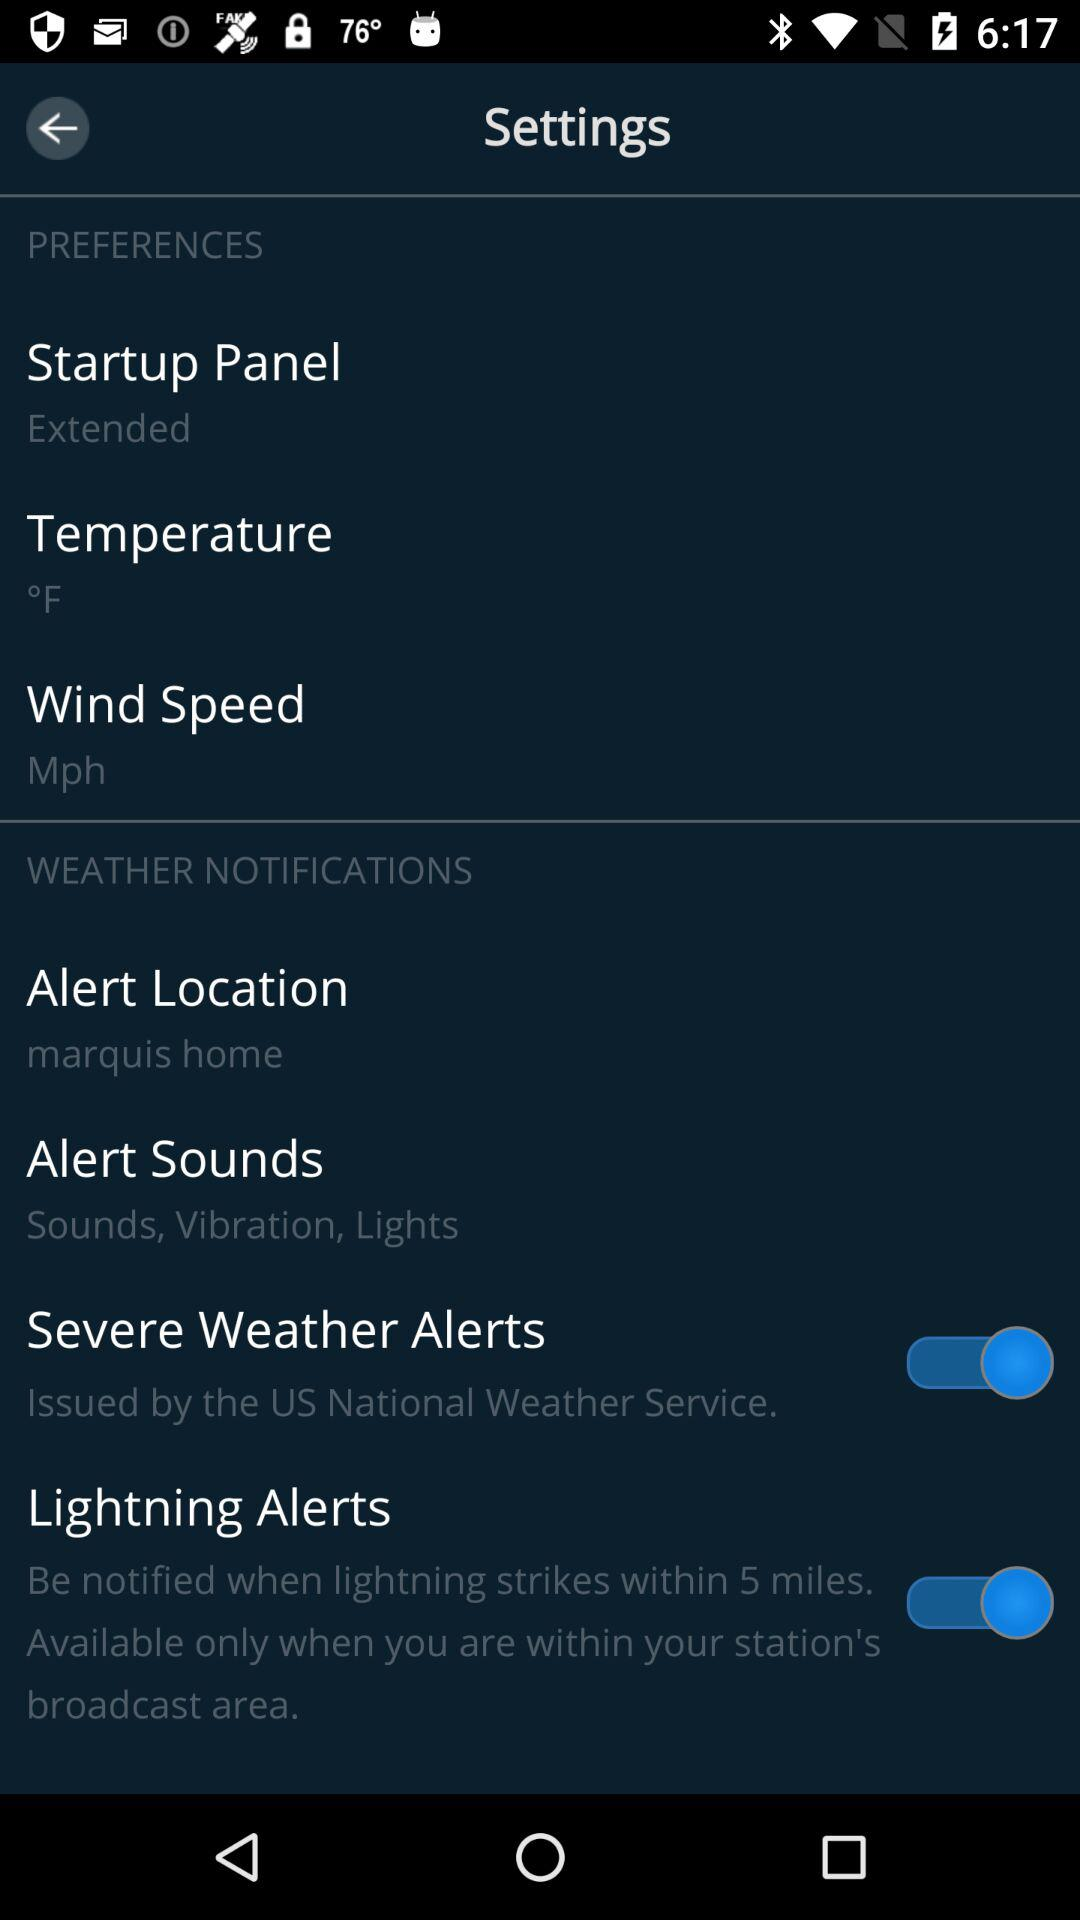What is the status of "Lightning Alerts"? The status of "Lightning Alerts" is "on". 